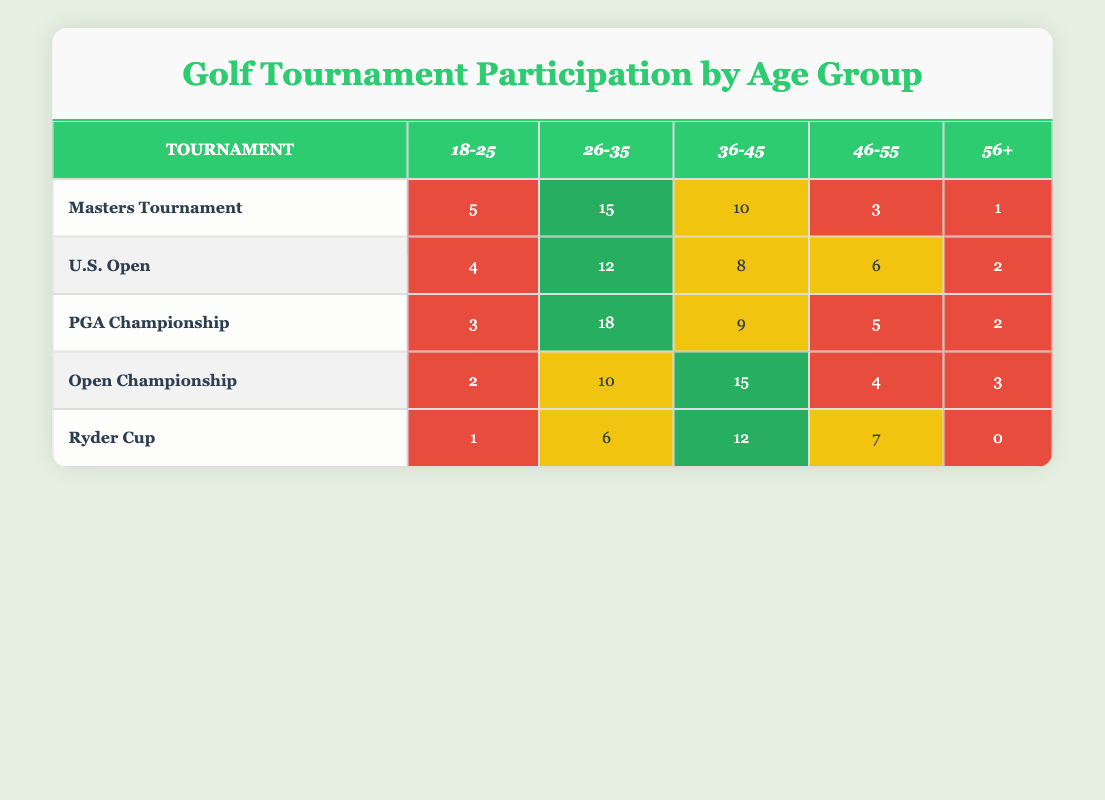What is the highest participation from the age group 26-35 in any tournament? Looking at the table, the age group 26-35 has the highest value of 18 in the PGA Championship.
Answer: 18 Which tournament had the least participation in the 56+ age group? When reviewing the 56+ age group, the Ryder Cup shows zero participation, while the other tournaments have at least one participant.
Answer: Ryder Cup What is the total participation of the age group 18-25 across all tournaments? To find this, I need to sum the values in the 18-25 column: (5 + 4 + 3 + 2 + 1) = 15.
Answer: 15 Is the participation of the age group 46-55 in the Masters Tournament greater than in the Open Championship? The participation in the Masters Tournament for the 46-55 age group is 3, while in the Open Championship, it is 4. Therefore, 3 is less than 4.
Answer: No What is the average participation for the age group 36-45 across all tournaments? For the age group 36-45, the values are (10 + 8 + 9 + 15 + 12). The total participation is 54, and there are 5 data points, so the average is 54/5 = 10.8.
Answer: 10.8 Which age group had the highest cumulative participation across all tournaments? Summing all age group participations: 18-25 (15), 26-35 (61), 36-45 (54), 46-55 (25), 56+ (8). 26-35 has the highest at 61.
Answer: 26-35 Did the Open Championship have more participants in the 18-25 age group than the Ryder Cup? The Open Championship had 2 participants in the 18-25 age group, while the Ryder Cup had only 1 participant. Thus, 2 is greater than 1.
Answer: Yes How many more players participated in the 46-55 age group of the U.S. Open than the Masters Tournament? In the U.S. Open, the participation in the 46-55 age group is 6, while in the Masters Tournament, it is 3. The difference is 6 - 3 = 3.
Answer: 3 